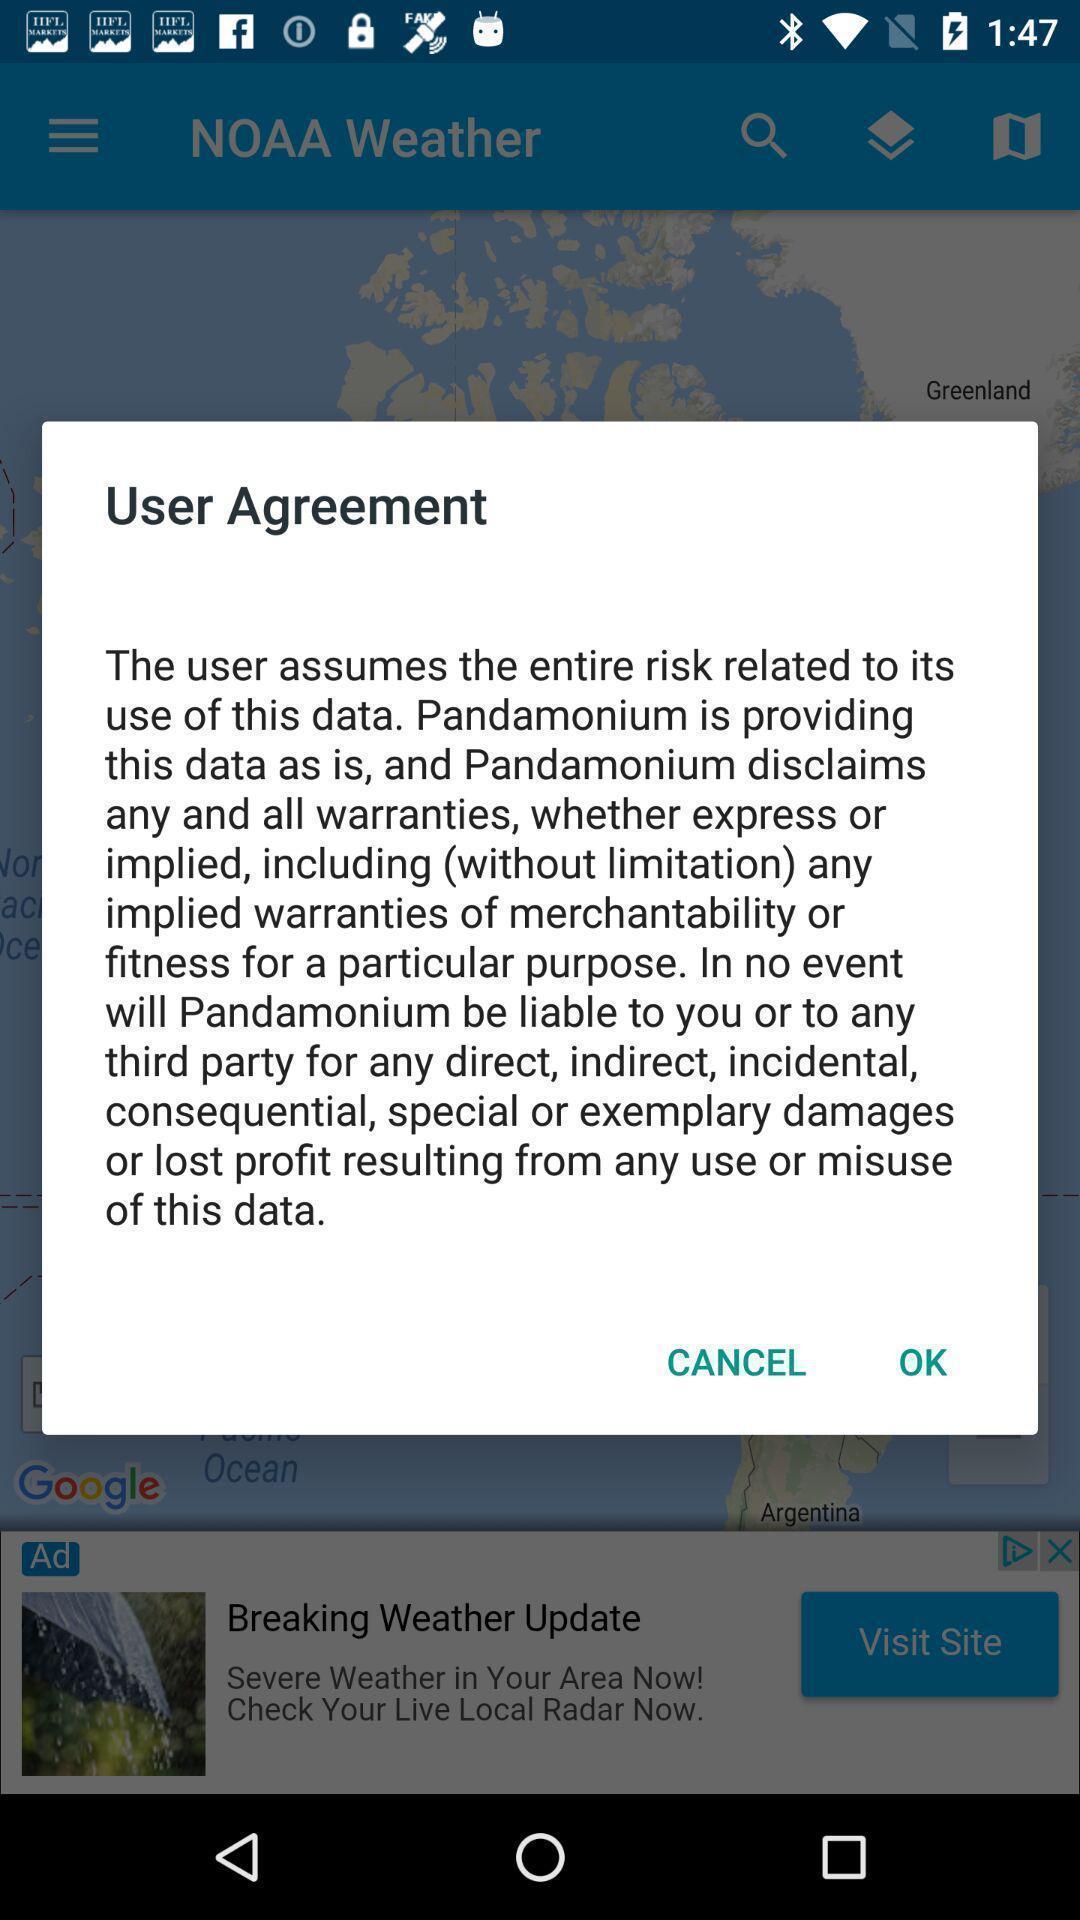Describe the key features of this screenshot. Pop-up showing user agreement of a forecaste app. 